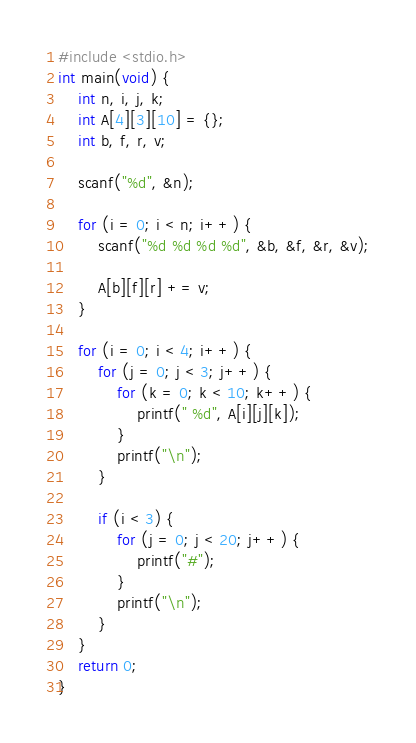Convert code to text. <code><loc_0><loc_0><loc_500><loc_500><_C_>#include <stdio.h>
int main(void) {
	int n, i, j, k;
	int A[4][3][10] = {};
	int b, f, r, v;

	scanf("%d", &n);

	for (i = 0; i < n; i++) {
		scanf("%d %d %d %d", &b, &f, &r, &v);

		A[b][f][r] += v;
	}

	for (i = 0; i < 4; i++) {
		for (j = 0; j < 3; j++) {
			for (k = 0; k < 10; k++) {
				printf(" %d", A[i][j][k]);
			}
			printf("\n");
		}

		if (i < 3) {
			for (j = 0; j < 20; j++) {
				printf("#");
			}
			printf("\n");
		}
	}
	return 0;
}</code> 